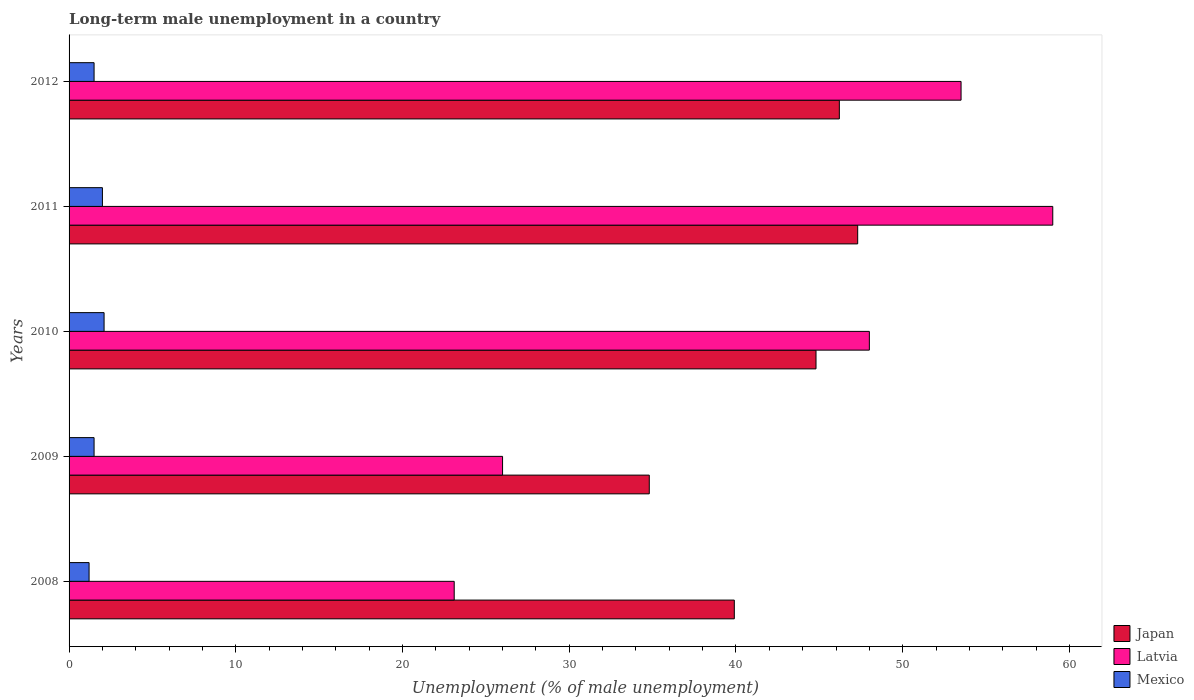How many groups of bars are there?
Your response must be concise. 5. Are the number of bars on each tick of the Y-axis equal?
Ensure brevity in your answer.  Yes. How many bars are there on the 2nd tick from the top?
Your answer should be compact. 3. How many bars are there on the 2nd tick from the bottom?
Offer a terse response. 3. What is the percentage of long-term unemployed male population in Japan in 2010?
Make the answer very short. 44.8. Across all years, what is the maximum percentage of long-term unemployed male population in Mexico?
Your response must be concise. 2.1. Across all years, what is the minimum percentage of long-term unemployed male population in Japan?
Ensure brevity in your answer.  34.8. What is the total percentage of long-term unemployed male population in Latvia in the graph?
Offer a very short reply. 209.6. What is the difference between the percentage of long-term unemployed male population in Latvia in 2008 and that in 2012?
Ensure brevity in your answer.  -30.4. What is the difference between the percentage of long-term unemployed male population in Mexico in 2010 and the percentage of long-term unemployed male population in Japan in 2009?
Your answer should be compact. -32.7. What is the average percentage of long-term unemployed male population in Latvia per year?
Offer a terse response. 41.92. In the year 2009, what is the difference between the percentage of long-term unemployed male population in Japan and percentage of long-term unemployed male population in Mexico?
Your response must be concise. 33.3. What is the ratio of the percentage of long-term unemployed male population in Latvia in 2008 to that in 2012?
Offer a very short reply. 0.43. Is the percentage of long-term unemployed male population in Latvia in 2010 less than that in 2011?
Keep it short and to the point. Yes. What is the difference between the highest and the second highest percentage of long-term unemployed male population in Japan?
Your answer should be compact. 1.1. What is the difference between the highest and the lowest percentage of long-term unemployed male population in Japan?
Offer a terse response. 12.5. What does the 1st bar from the top in 2008 represents?
Provide a short and direct response. Mexico. How many bars are there?
Provide a succinct answer. 15. Are all the bars in the graph horizontal?
Keep it short and to the point. Yes. What is the difference between two consecutive major ticks on the X-axis?
Make the answer very short. 10. Does the graph contain grids?
Make the answer very short. No. Where does the legend appear in the graph?
Your answer should be compact. Bottom right. How many legend labels are there?
Provide a short and direct response. 3. What is the title of the graph?
Offer a terse response. Long-term male unemployment in a country. Does "Small states" appear as one of the legend labels in the graph?
Provide a succinct answer. No. What is the label or title of the X-axis?
Ensure brevity in your answer.  Unemployment (% of male unemployment). What is the Unemployment (% of male unemployment) of Japan in 2008?
Offer a terse response. 39.9. What is the Unemployment (% of male unemployment) in Latvia in 2008?
Offer a very short reply. 23.1. What is the Unemployment (% of male unemployment) of Mexico in 2008?
Your answer should be very brief. 1.2. What is the Unemployment (% of male unemployment) of Japan in 2009?
Provide a short and direct response. 34.8. What is the Unemployment (% of male unemployment) in Mexico in 2009?
Make the answer very short. 1.5. What is the Unemployment (% of male unemployment) of Japan in 2010?
Provide a succinct answer. 44.8. What is the Unemployment (% of male unemployment) of Mexico in 2010?
Keep it short and to the point. 2.1. What is the Unemployment (% of male unemployment) of Japan in 2011?
Keep it short and to the point. 47.3. What is the Unemployment (% of male unemployment) of Latvia in 2011?
Give a very brief answer. 59. What is the Unemployment (% of male unemployment) in Mexico in 2011?
Ensure brevity in your answer.  2. What is the Unemployment (% of male unemployment) of Japan in 2012?
Your answer should be very brief. 46.2. What is the Unemployment (% of male unemployment) in Latvia in 2012?
Your response must be concise. 53.5. What is the Unemployment (% of male unemployment) of Mexico in 2012?
Offer a terse response. 1.5. Across all years, what is the maximum Unemployment (% of male unemployment) of Japan?
Your answer should be compact. 47.3. Across all years, what is the maximum Unemployment (% of male unemployment) in Latvia?
Offer a very short reply. 59. Across all years, what is the maximum Unemployment (% of male unemployment) of Mexico?
Offer a very short reply. 2.1. Across all years, what is the minimum Unemployment (% of male unemployment) in Japan?
Your answer should be compact. 34.8. Across all years, what is the minimum Unemployment (% of male unemployment) of Latvia?
Your answer should be compact. 23.1. Across all years, what is the minimum Unemployment (% of male unemployment) of Mexico?
Offer a very short reply. 1.2. What is the total Unemployment (% of male unemployment) of Japan in the graph?
Provide a succinct answer. 213. What is the total Unemployment (% of male unemployment) in Latvia in the graph?
Your answer should be compact. 209.6. What is the difference between the Unemployment (% of male unemployment) in Mexico in 2008 and that in 2009?
Ensure brevity in your answer.  -0.3. What is the difference between the Unemployment (% of male unemployment) of Latvia in 2008 and that in 2010?
Offer a very short reply. -24.9. What is the difference between the Unemployment (% of male unemployment) in Mexico in 2008 and that in 2010?
Your answer should be compact. -0.9. What is the difference between the Unemployment (% of male unemployment) in Latvia in 2008 and that in 2011?
Offer a very short reply. -35.9. What is the difference between the Unemployment (% of male unemployment) in Mexico in 2008 and that in 2011?
Provide a short and direct response. -0.8. What is the difference between the Unemployment (% of male unemployment) in Latvia in 2008 and that in 2012?
Keep it short and to the point. -30.4. What is the difference between the Unemployment (% of male unemployment) in Japan in 2009 and that in 2010?
Make the answer very short. -10. What is the difference between the Unemployment (% of male unemployment) in Latvia in 2009 and that in 2010?
Keep it short and to the point. -22. What is the difference between the Unemployment (% of male unemployment) in Mexico in 2009 and that in 2010?
Give a very brief answer. -0.6. What is the difference between the Unemployment (% of male unemployment) of Latvia in 2009 and that in 2011?
Provide a succinct answer. -33. What is the difference between the Unemployment (% of male unemployment) of Japan in 2009 and that in 2012?
Ensure brevity in your answer.  -11.4. What is the difference between the Unemployment (% of male unemployment) of Latvia in 2009 and that in 2012?
Ensure brevity in your answer.  -27.5. What is the difference between the Unemployment (% of male unemployment) in Mexico in 2009 and that in 2012?
Keep it short and to the point. 0. What is the difference between the Unemployment (% of male unemployment) in Latvia in 2010 and that in 2011?
Offer a very short reply. -11. What is the difference between the Unemployment (% of male unemployment) in Mexico in 2010 and that in 2011?
Keep it short and to the point. 0.1. What is the difference between the Unemployment (% of male unemployment) of Japan in 2010 and that in 2012?
Offer a terse response. -1.4. What is the difference between the Unemployment (% of male unemployment) of Mexico in 2010 and that in 2012?
Ensure brevity in your answer.  0.6. What is the difference between the Unemployment (% of male unemployment) of Latvia in 2011 and that in 2012?
Offer a terse response. 5.5. What is the difference between the Unemployment (% of male unemployment) of Japan in 2008 and the Unemployment (% of male unemployment) of Latvia in 2009?
Provide a succinct answer. 13.9. What is the difference between the Unemployment (% of male unemployment) of Japan in 2008 and the Unemployment (% of male unemployment) of Mexico in 2009?
Keep it short and to the point. 38.4. What is the difference between the Unemployment (% of male unemployment) in Latvia in 2008 and the Unemployment (% of male unemployment) in Mexico in 2009?
Offer a terse response. 21.6. What is the difference between the Unemployment (% of male unemployment) in Japan in 2008 and the Unemployment (% of male unemployment) in Mexico in 2010?
Offer a very short reply. 37.8. What is the difference between the Unemployment (% of male unemployment) of Latvia in 2008 and the Unemployment (% of male unemployment) of Mexico in 2010?
Provide a short and direct response. 21. What is the difference between the Unemployment (% of male unemployment) in Japan in 2008 and the Unemployment (% of male unemployment) in Latvia in 2011?
Keep it short and to the point. -19.1. What is the difference between the Unemployment (% of male unemployment) in Japan in 2008 and the Unemployment (% of male unemployment) in Mexico in 2011?
Your answer should be compact. 37.9. What is the difference between the Unemployment (% of male unemployment) of Latvia in 2008 and the Unemployment (% of male unemployment) of Mexico in 2011?
Offer a terse response. 21.1. What is the difference between the Unemployment (% of male unemployment) of Japan in 2008 and the Unemployment (% of male unemployment) of Latvia in 2012?
Your answer should be compact. -13.6. What is the difference between the Unemployment (% of male unemployment) in Japan in 2008 and the Unemployment (% of male unemployment) in Mexico in 2012?
Provide a short and direct response. 38.4. What is the difference between the Unemployment (% of male unemployment) in Latvia in 2008 and the Unemployment (% of male unemployment) in Mexico in 2012?
Ensure brevity in your answer.  21.6. What is the difference between the Unemployment (% of male unemployment) in Japan in 2009 and the Unemployment (% of male unemployment) in Latvia in 2010?
Offer a very short reply. -13.2. What is the difference between the Unemployment (% of male unemployment) of Japan in 2009 and the Unemployment (% of male unemployment) of Mexico in 2010?
Give a very brief answer. 32.7. What is the difference between the Unemployment (% of male unemployment) in Latvia in 2009 and the Unemployment (% of male unemployment) in Mexico in 2010?
Offer a very short reply. 23.9. What is the difference between the Unemployment (% of male unemployment) in Japan in 2009 and the Unemployment (% of male unemployment) in Latvia in 2011?
Make the answer very short. -24.2. What is the difference between the Unemployment (% of male unemployment) of Japan in 2009 and the Unemployment (% of male unemployment) of Mexico in 2011?
Ensure brevity in your answer.  32.8. What is the difference between the Unemployment (% of male unemployment) in Japan in 2009 and the Unemployment (% of male unemployment) in Latvia in 2012?
Keep it short and to the point. -18.7. What is the difference between the Unemployment (% of male unemployment) of Japan in 2009 and the Unemployment (% of male unemployment) of Mexico in 2012?
Keep it short and to the point. 33.3. What is the difference between the Unemployment (% of male unemployment) of Japan in 2010 and the Unemployment (% of male unemployment) of Mexico in 2011?
Offer a very short reply. 42.8. What is the difference between the Unemployment (% of male unemployment) of Japan in 2010 and the Unemployment (% of male unemployment) of Mexico in 2012?
Your answer should be compact. 43.3. What is the difference between the Unemployment (% of male unemployment) of Latvia in 2010 and the Unemployment (% of male unemployment) of Mexico in 2012?
Your response must be concise. 46.5. What is the difference between the Unemployment (% of male unemployment) in Japan in 2011 and the Unemployment (% of male unemployment) in Latvia in 2012?
Give a very brief answer. -6.2. What is the difference between the Unemployment (% of male unemployment) of Japan in 2011 and the Unemployment (% of male unemployment) of Mexico in 2012?
Your answer should be compact. 45.8. What is the difference between the Unemployment (% of male unemployment) of Latvia in 2011 and the Unemployment (% of male unemployment) of Mexico in 2012?
Offer a terse response. 57.5. What is the average Unemployment (% of male unemployment) in Japan per year?
Keep it short and to the point. 42.6. What is the average Unemployment (% of male unemployment) of Latvia per year?
Give a very brief answer. 41.92. What is the average Unemployment (% of male unemployment) in Mexico per year?
Your answer should be very brief. 1.66. In the year 2008, what is the difference between the Unemployment (% of male unemployment) in Japan and Unemployment (% of male unemployment) in Latvia?
Your answer should be compact. 16.8. In the year 2008, what is the difference between the Unemployment (% of male unemployment) in Japan and Unemployment (% of male unemployment) in Mexico?
Give a very brief answer. 38.7. In the year 2008, what is the difference between the Unemployment (% of male unemployment) of Latvia and Unemployment (% of male unemployment) of Mexico?
Offer a very short reply. 21.9. In the year 2009, what is the difference between the Unemployment (% of male unemployment) in Japan and Unemployment (% of male unemployment) in Latvia?
Your answer should be very brief. 8.8. In the year 2009, what is the difference between the Unemployment (% of male unemployment) in Japan and Unemployment (% of male unemployment) in Mexico?
Make the answer very short. 33.3. In the year 2010, what is the difference between the Unemployment (% of male unemployment) of Japan and Unemployment (% of male unemployment) of Latvia?
Your answer should be compact. -3.2. In the year 2010, what is the difference between the Unemployment (% of male unemployment) in Japan and Unemployment (% of male unemployment) in Mexico?
Give a very brief answer. 42.7. In the year 2010, what is the difference between the Unemployment (% of male unemployment) of Latvia and Unemployment (% of male unemployment) of Mexico?
Your answer should be very brief. 45.9. In the year 2011, what is the difference between the Unemployment (% of male unemployment) in Japan and Unemployment (% of male unemployment) in Mexico?
Keep it short and to the point. 45.3. In the year 2012, what is the difference between the Unemployment (% of male unemployment) of Japan and Unemployment (% of male unemployment) of Latvia?
Make the answer very short. -7.3. In the year 2012, what is the difference between the Unemployment (% of male unemployment) of Japan and Unemployment (% of male unemployment) of Mexico?
Make the answer very short. 44.7. In the year 2012, what is the difference between the Unemployment (% of male unemployment) in Latvia and Unemployment (% of male unemployment) in Mexico?
Provide a succinct answer. 52. What is the ratio of the Unemployment (% of male unemployment) of Japan in 2008 to that in 2009?
Your answer should be very brief. 1.15. What is the ratio of the Unemployment (% of male unemployment) of Latvia in 2008 to that in 2009?
Your response must be concise. 0.89. What is the ratio of the Unemployment (% of male unemployment) of Japan in 2008 to that in 2010?
Make the answer very short. 0.89. What is the ratio of the Unemployment (% of male unemployment) in Latvia in 2008 to that in 2010?
Your answer should be compact. 0.48. What is the ratio of the Unemployment (% of male unemployment) of Mexico in 2008 to that in 2010?
Keep it short and to the point. 0.57. What is the ratio of the Unemployment (% of male unemployment) of Japan in 2008 to that in 2011?
Offer a terse response. 0.84. What is the ratio of the Unemployment (% of male unemployment) in Latvia in 2008 to that in 2011?
Offer a very short reply. 0.39. What is the ratio of the Unemployment (% of male unemployment) of Mexico in 2008 to that in 2011?
Offer a terse response. 0.6. What is the ratio of the Unemployment (% of male unemployment) of Japan in 2008 to that in 2012?
Ensure brevity in your answer.  0.86. What is the ratio of the Unemployment (% of male unemployment) of Latvia in 2008 to that in 2012?
Offer a very short reply. 0.43. What is the ratio of the Unemployment (% of male unemployment) in Mexico in 2008 to that in 2012?
Your answer should be compact. 0.8. What is the ratio of the Unemployment (% of male unemployment) of Japan in 2009 to that in 2010?
Your response must be concise. 0.78. What is the ratio of the Unemployment (% of male unemployment) of Latvia in 2009 to that in 2010?
Offer a very short reply. 0.54. What is the ratio of the Unemployment (% of male unemployment) of Mexico in 2009 to that in 2010?
Make the answer very short. 0.71. What is the ratio of the Unemployment (% of male unemployment) of Japan in 2009 to that in 2011?
Provide a short and direct response. 0.74. What is the ratio of the Unemployment (% of male unemployment) of Latvia in 2009 to that in 2011?
Keep it short and to the point. 0.44. What is the ratio of the Unemployment (% of male unemployment) of Mexico in 2009 to that in 2011?
Give a very brief answer. 0.75. What is the ratio of the Unemployment (% of male unemployment) of Japan in 2009 to that in 2012?
Give a very brief answer. 0.75. What is the ratio of the Unemployment (% of male unemployment) in Latvia in 2009 to that in 2012?
Offer a very short reply. 0.49. What is the ratio of the Unemployment (% of male unemployment) in Mexico in 2009 to that in 2012?
Ensure brevity in your answer.  1. What is the ratio of the Unemployment (% of male unemployment) in Japan in 2010 to that in 2011?
Your response must be concise. 0.95. What is the ratio of the Unemployment (% of male unemployment) in Latvia in 2010 to that in 2011?
Offer a terse response. 0.81. What is the ratio of the Unemployment (% of male unemployment) of Mexico in 2010 to that in 2011?
Provide a short and direct response. 1.05. What is the ratio of the Unemployment (% of male unemployment) in Japan in 2010 to that in 2012?
Your answer should be compact. 0.97. What is the ratio of the Unemployment (% of male unemployment) in Latvia in 2010 to that in 2012?
Offer a very short reply. 0.9. What is the ratio of the Unemployment (% of male unemployment) in Mexico in 2010 to that in 2012?
Your response must be concise. 1.4. What is the ratio of the Unemployment (% of male unemployment) of Japan in 2011 to that in 2012?
Provide a succinct answer. 1.02. What is the ratio of the Unemployment (% of male unemployment) of Latvia in 2011 to that in 2012?
Keep it short and to the point. 1.1. What is the ratio of the Unemployment (% of male unemployment) of Mexico in 2011 to that in 2012?
Keep it short and to the point. 1.33. What is the difference between the highest and the lowest Unemployment (% of male unemployment) of Latvia?
Keep it short and to the point. 35.9. 